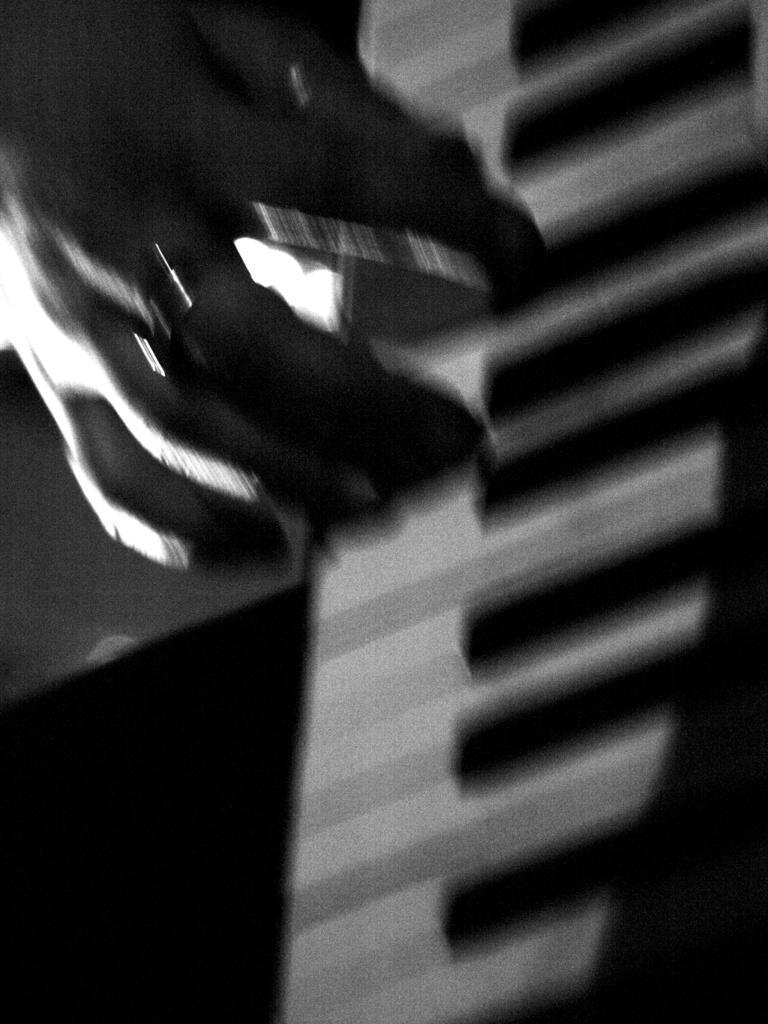How would you summarize this image in a sentence or two? In this image I can see a person's hand on the piano keys, I can see the person is wearing a ring. 